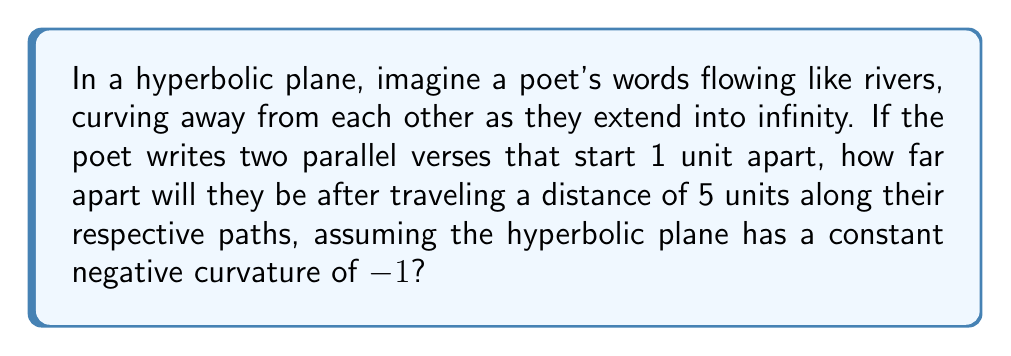Provide a solution to this math problem. To solve this problem, we'll use the concept of hyperbolic geometry and the formula for distance between geodesics in a hyperbolic plane. Let's break it down step-by-step:

1. In hyperbolic geometry, parallel lines diverge exponentially.

2. The formula for the distance $d$ between two geodesics (our parallel verses) after traveling a distance $x$ along them, given an initial separation $a$ and curvature $K$, is:

   $$d = a \cosh(\sqrt{-K}x)$$

3. We're given:
   - Initial separation: $a = 1$ unit
   - Distance traveled: $x = 5$ units
   - Curvature: $K = -1$

4. Substituting these values into our formula:

   $$d = 1 \cdot \cosh(\sqrt{1} \cdot 5)$$

5. Simplify:
   $$d = \cosh(5)$$

6. Calculate the hyperbolic cosine:
   $$d \approx 74.21$$

Therefore, after traveling 5 units, the poet's parallel verses will be approximately 74.21 units apart in this hyperbolic plane.

This extreme divergence illustrates the nature of hyperbolic geometry, where parallel lines spread apart much more rapidly than in Euclidean space, mirroring how ideas in poetry can start close but lead to vastly different interpretations.
Answer: $\cosh(5) \approx 74.21$ units 